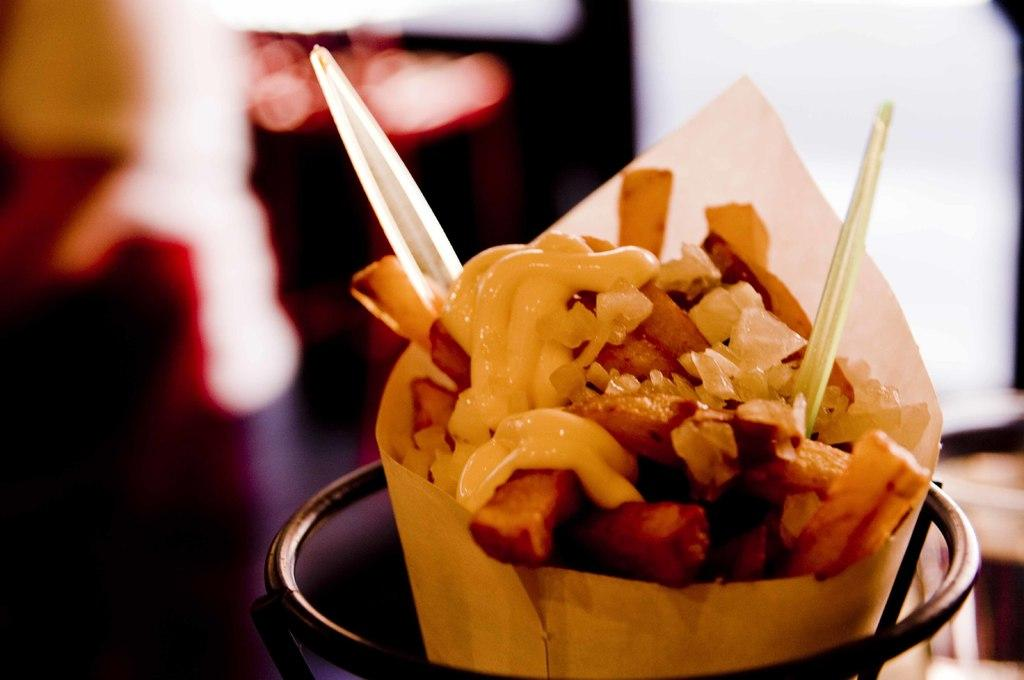What type of food is in the image? The food in the image is in a paper-cone. How is the food contained in the image? The food is contained in a paper-cone, and there is a metal object around the food. Can you describe the background of the image? The background of the image is blurred. What type of snakes can be seen playing chess in the image? There are no snakes or chessboards present in the image. What kind of ornament is hanging from the metal object in the image? There is no ornament hanging from the metal object in the image; it is simply around the food. 